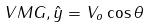<formula> <loc_0><loc_0><loc_500><loc_500>V M G , \hat { y } = V _ { o } \cos \theta</formula> 